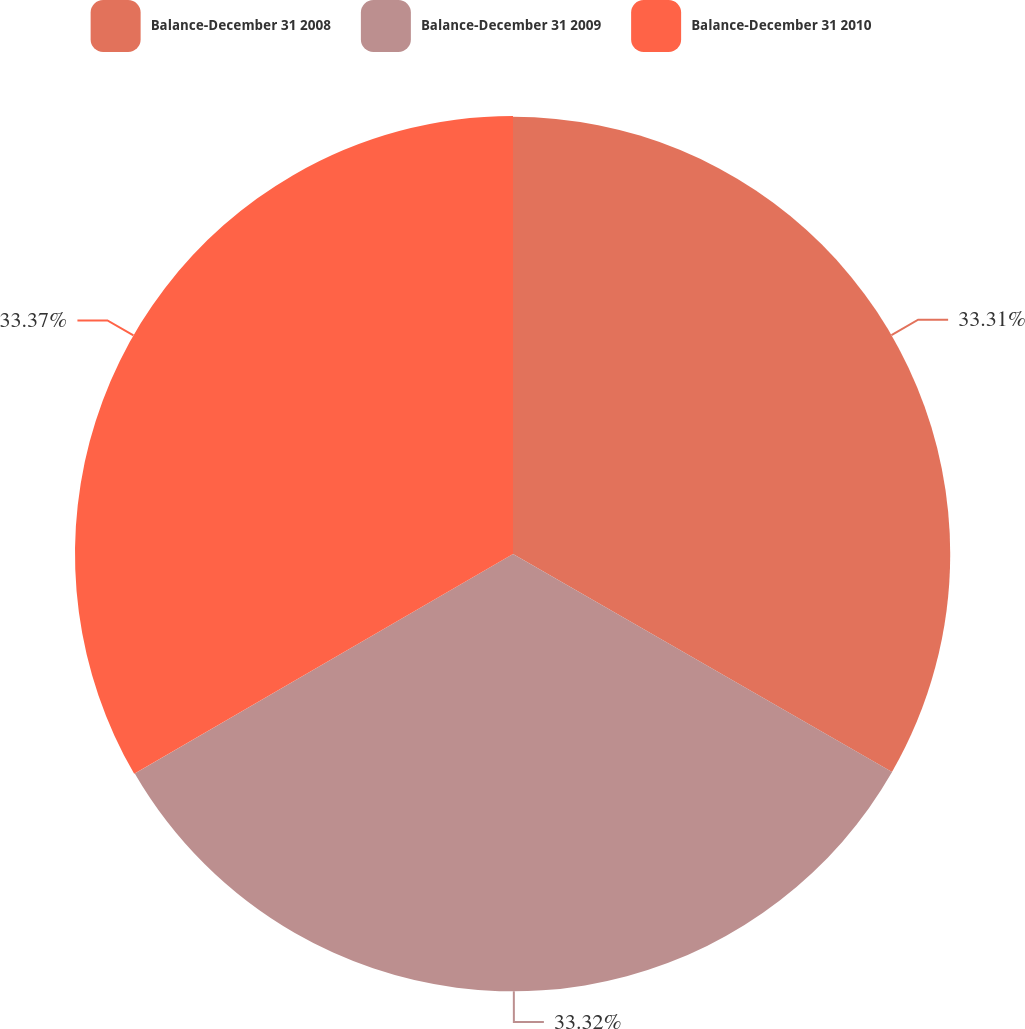Convert chart to OTSL. <chart><loc_0><loc_0><loc_500><loc_500><pie_chart><fcel>Balance-December 31 2008<fcel>Balance-December 31 2009<fcel>Balance-December 31 2010<nl><fcel>33.31%<fcel>33.32%<fcel>33.37%<nl></chart> 